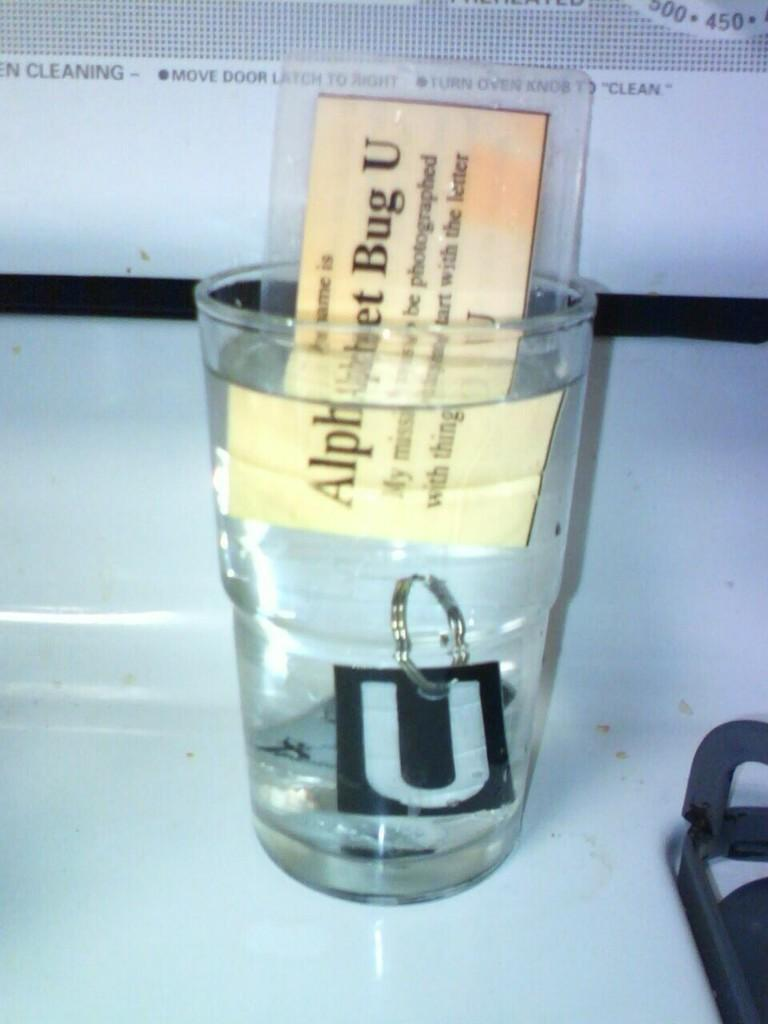Provide a one-sentence caption for the provided image. A clear glass has water and a card that says Alphabet Bug U in it. 